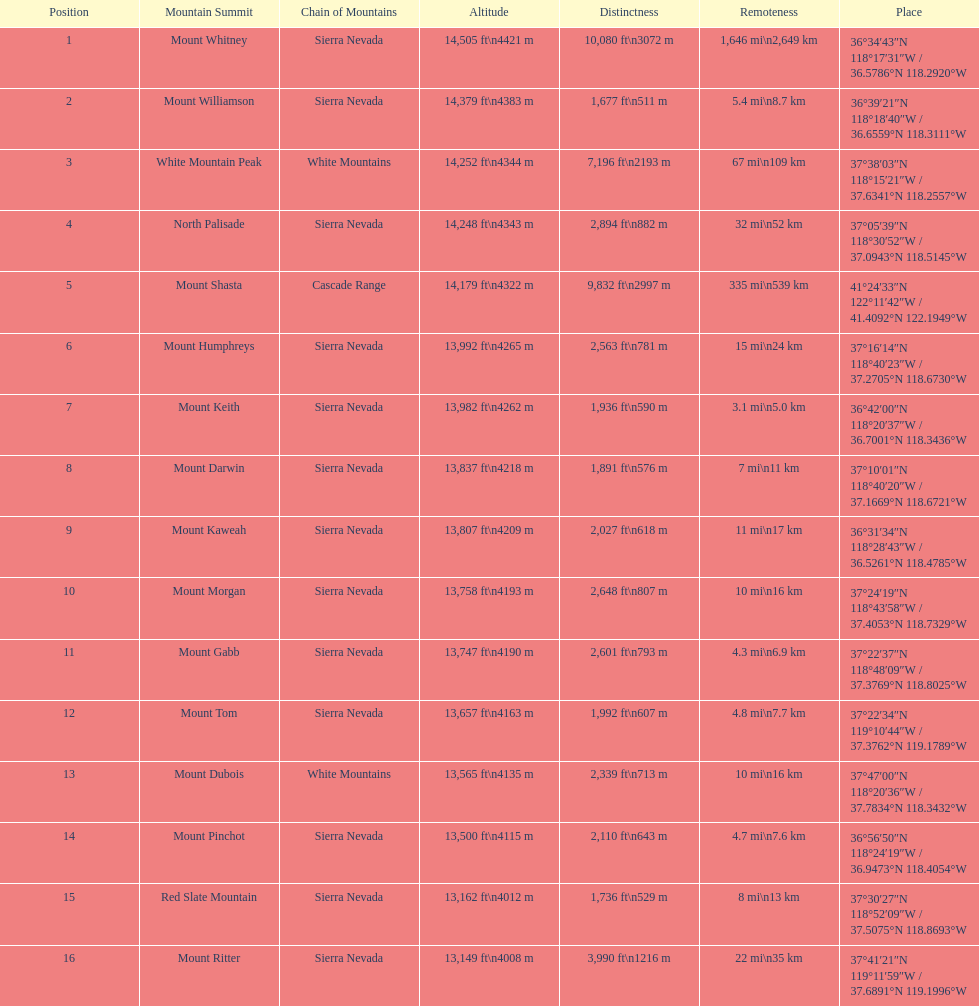What is the only mountain peak listed for the cascade range? Mount Shasta. 